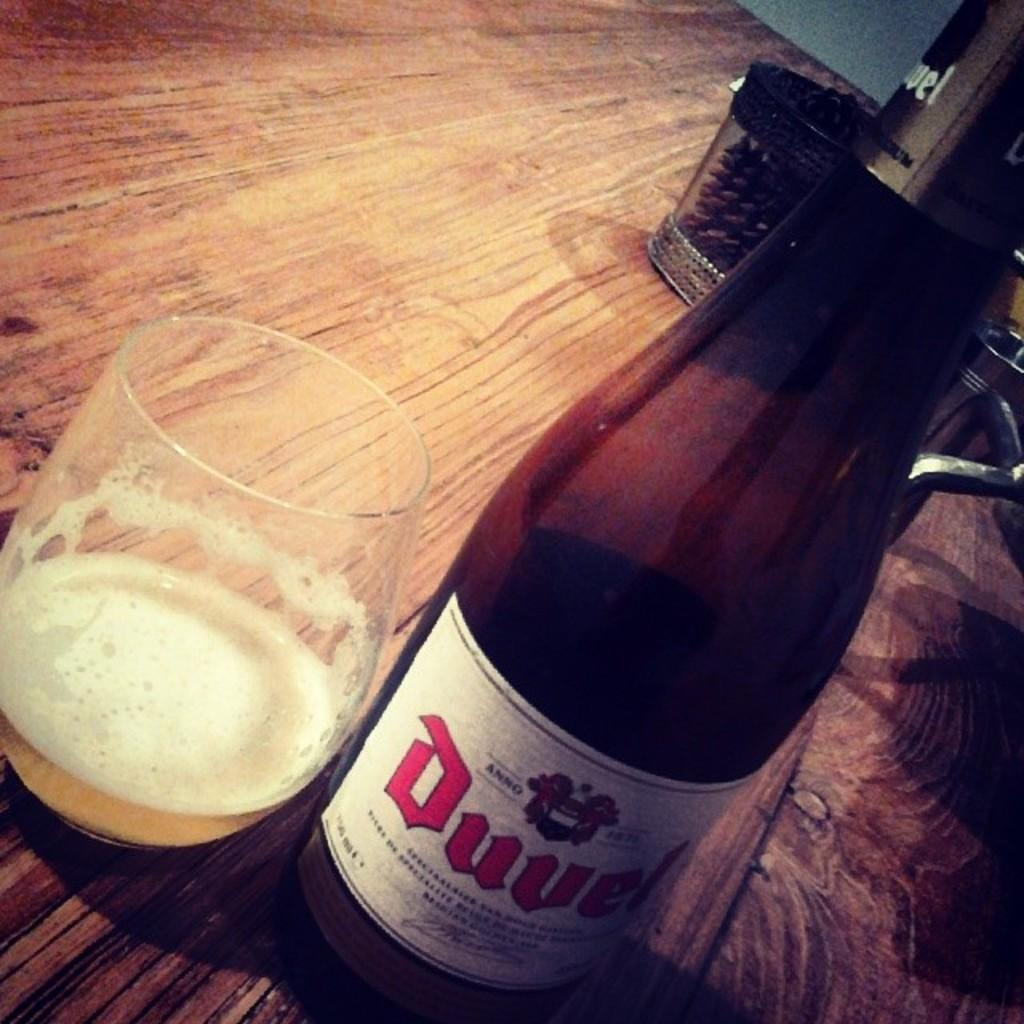What is present in the image that can hold a liquid? There is a bottle and a glass in the image that can hold a liquid. What is inside the glass in the image? There is a drink in the glass in the image. Where are the bottle, glass, and drink located? The bottle, glass, and drink are on a table in the image. What type of development is taking place in the image? There is no development project or activity depicted in the image; it features a bottle, a glass, and a drink on a table. Can you tell me how the father is interacting with the bottle in the image? There is no father present in the image, and therefore no interaction with the bottle can be observed. 